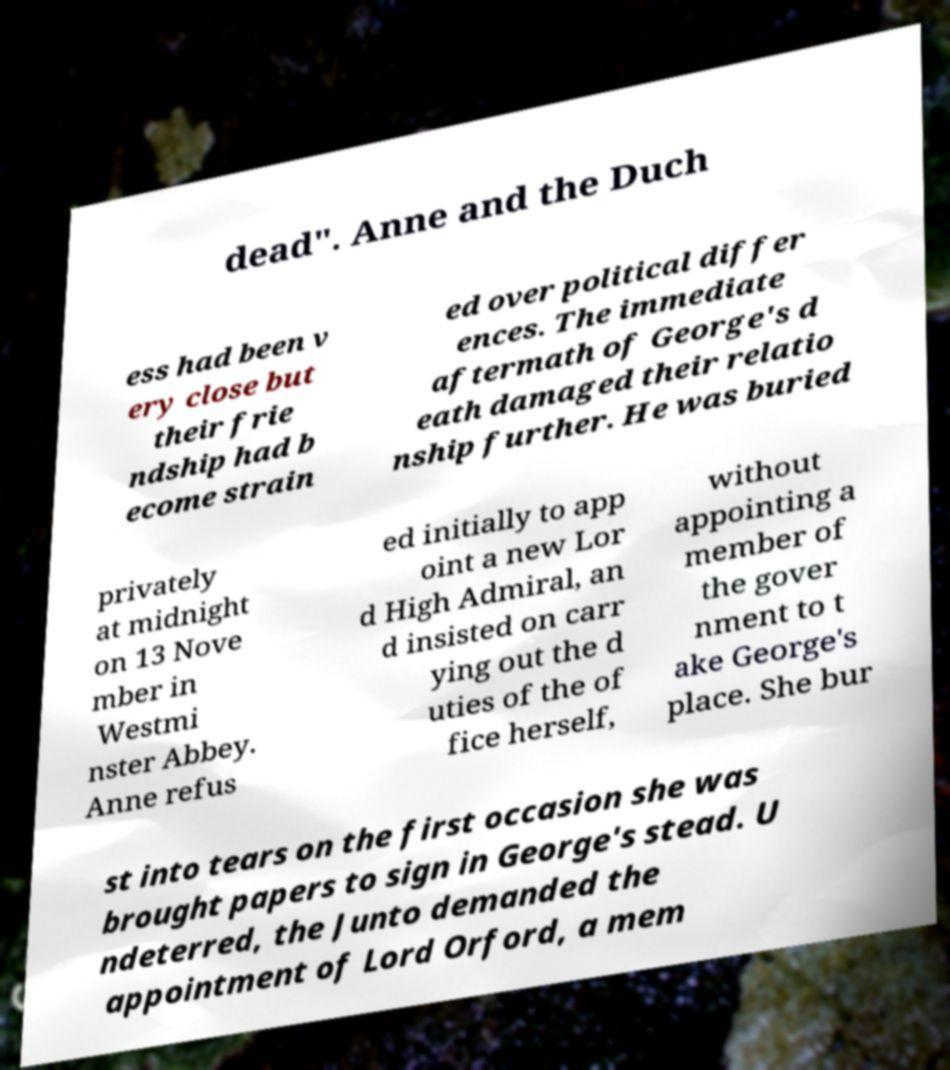Could you extract and type out the text from this image? dead". Anne and the Duch ess had been v ery close but their frie ndship had b ecome strain ed over political differ ences. The immediate aftermath of George's d eath damaged their relatio nship further. He was buried privately at midnight on 13 Nove mber in Westmi nster Abbey. Anne refus ed initially to app oint a new Lor d High Admiral, an d insisted on carr ying out the d uties of the of fice herself, without appointing a member of the gover nment to t ake George's place. She bur st into tears on the first occasion she was brought papers to sign in George's stead. U ndeterred, the Junto demanded the appointment of Lord Orford, a mem 